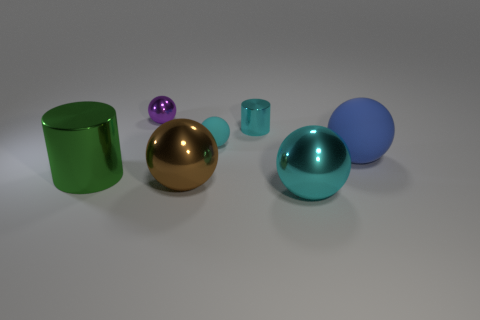Which object stands out the most due to its color, and why might that be the case? The green cylindrical object commands attention with its vibrant hue. The use of a contrasting color makes it visually prominent, and in design, such standout colors can be intentional to draw the viewer's eye or indicate importance. 